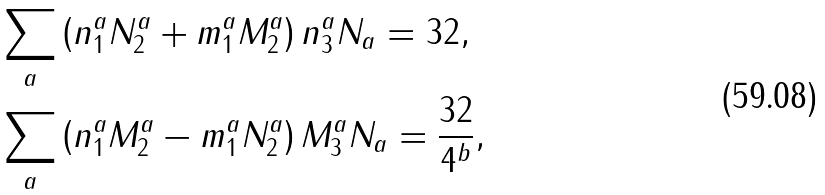<formula> <loc_0><loc_0><loc_500><loc_500>& \sum _ { a } \left ( n ^ { a } _ { 1 } N ^ { a } _ { 2 } + m ^ { a } _ { 1 } M ^ { a } _ { 2 } \right ) n ^ { a } _ { 3 } N _ { a } = 3 2 , \\ & \sum _ { a } \left ( n ^ { a } _ { 1 } M ^ { a } _ { 2 } - m ^ { a } _ { 1 } N ^ { a } _ { 2 } \right ) M ^ { a } _ { 3 } N _ { a } = \frac { 3 2 } { 4 ^ { b } } , \\</formula> 